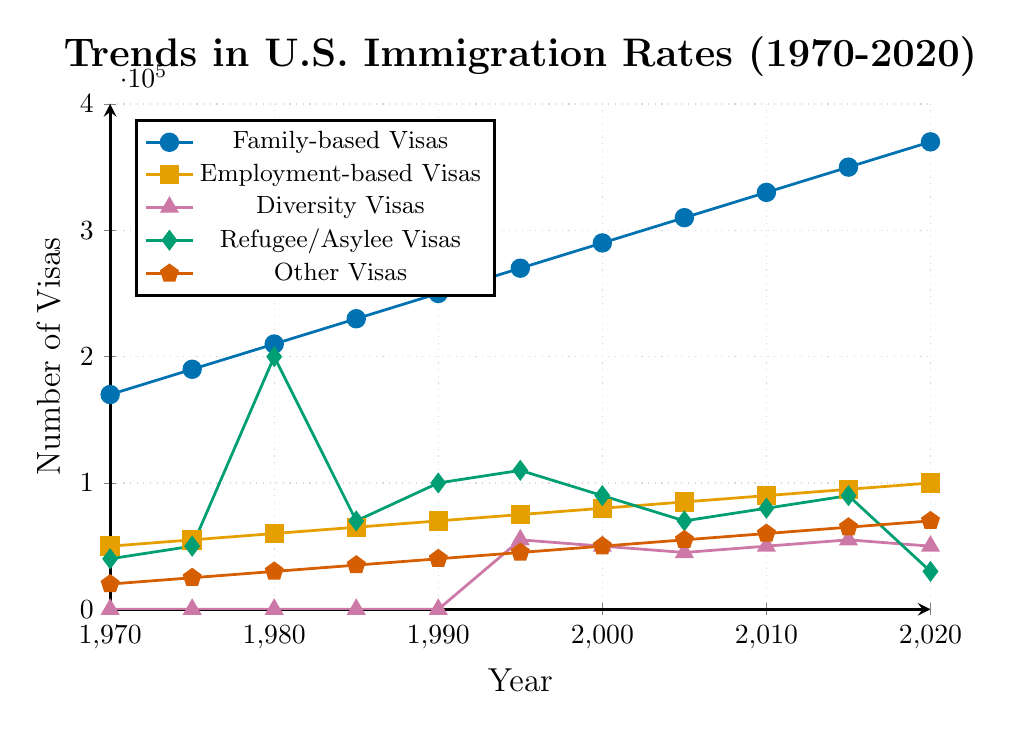What is the trend for Family-based Visas from 1970 to 2020? The figure shows that Family-based Visas have been steadily increasing over the 50-year period, starting from 170,000 in 1970 to 370,000 in 2020.
Answer: An upward trend During which years did the number of Refugee/Asylee Visas peak, and what was the approximate value at its peak? The Refugee/Asylee Visas peaked in 1980, visible on the chart where the data point reaches the highest y-value for this category around 200,000.
Answer: 1980, 200,000 Compare the number of Employment-based Visas in 1970 and 2020. Which year had higher numbers, and by how much? The figure shows 50,000 Employment-based Visas in 1970 and 100,000 in 2020. Calculating the difference: 100,000 - 50,000 = 50,000.
Answer: 2020, by 50,000 What was the average number of Family-based Visas issued over the decades provided? Summing up the Family-based Visas over the years: 170,000 + 190,000 + 210,000 + 230,000 + 250,000 + 270,000 + 290,000 + 310,000 + 330,000 + 350,000 + 370,000 = 2,970,000. Dividing by the number of years (11): 2,970,000 / 11 = 270,000.
Answer: 270,000 How did the number of Diversity Visas change from 1995 to 2020? Starting at 55,000 in 1995, Diversity Visas show slight fluctuations but remain relatively stable around 50,000 to 55,000, with no significant upward or downward trend.
Answer: Remained stable What is the relationship between Refugee/Asylee Visas and Other Visas in 2020? In 2020, Refugee/Asylee Visas drop to 30,000, while Other Visas rise to 70,000. Refugee/Asylee Visas are less than half the number of Other Visas.
Answer: Refugee/Asylee Visas are less than half the number of Other Visas Which visa category saw the most significant change in numbers between 1970 and 2020? Family-based Visas increased from 170,000 to 370,000, an increase of 200,000, which is the most significant change compared to other categories.
Answer: Family-based Visas How do the trends for Employment-based Visas and Family-based Visas compare? Both categories show an upward trend, but Family-based Visas increase at a steeper rate than Employment-based Visas over the 50-year period.
Answer: Both increased, Family-based more steeply Identify any visa category that remained constant in its numbers for any significant period within the given range. Diversity Visas start at zero and then appear stable around 50,000 - 55,000 from 1995 onwards.
Answer: Diversity Visas remained constant around 50,000 - 55,000 